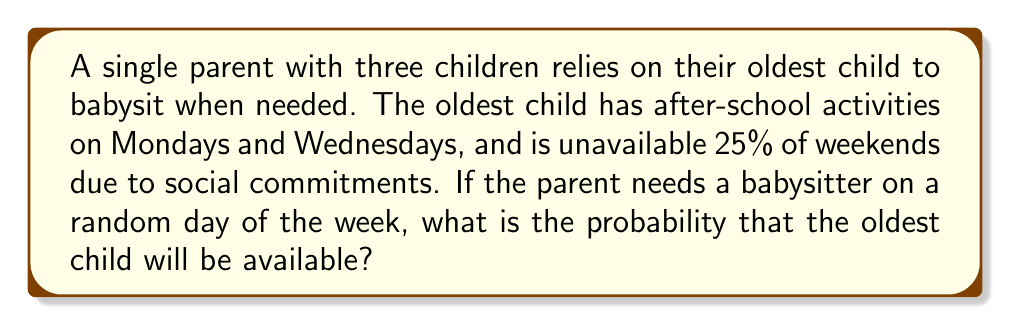Show me your answer to this math problem. Let's approach this step-by-step:

1) First, we need to calculate the probability of the oldest child being available on weekdays and weekends separately.

2) For weekdays:
   - There are 5 weekdays in total.
   - The child is unavailable on 2 days (Monday and Wednesday).
   - So, the child is available on 3 out of 5 weekdays.
   - Probability of availability on a weekday = $\frac{3}{5} = 0.6$

3) For weekends:
   - The child is available 75% of weekends (as they are unavailable 25% of the time).
   - Probability of availability on a weekend = $0.75$

4) Now, we need to combine these probabilities, considering that any given day has a $\frac{5}{7}$ chance of being a weekday and a $\frac{2}{7}$ chance of being a weekend day.

5) We can use the law of total probability:

   $$P(\text{Available}) = P(\text{Available}|\text{Weekday}) \cdot P(\text{Weekday}) + P(\text{Available}|\text{Weekend}) \cdot P(\text{Weekend})$$

6) Plugging in the values:

   $$P(\text{Available}) = 0.6 \cdot \frac{5}{7} + 0.75 \cdot \frac{2}{7}$$

7) Calculating:
   $$P(\text{Available}) = \frac{3}{7} + \frac{1.5}{7} = \frac{4.5}{7} \approx 0.6429$$

Thus, the probability that the oldest child will be available on a random day is approximately 0.6429 or about 64.29%.
Answer: $\frac{4.5}{7}$ or approximately 0.6429 